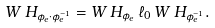<formula> <loc_0><loc_0><loc_500><loc_500>W \, H _ { \phi _ { e } \cdot \phi _ { e } ^ { - 1 } } = W \, H _ { \phi _ { e } } \, \ell _ { 0 } \, W \, H _ { \phi _ { e } ^ { - 1 } } .</formula> 